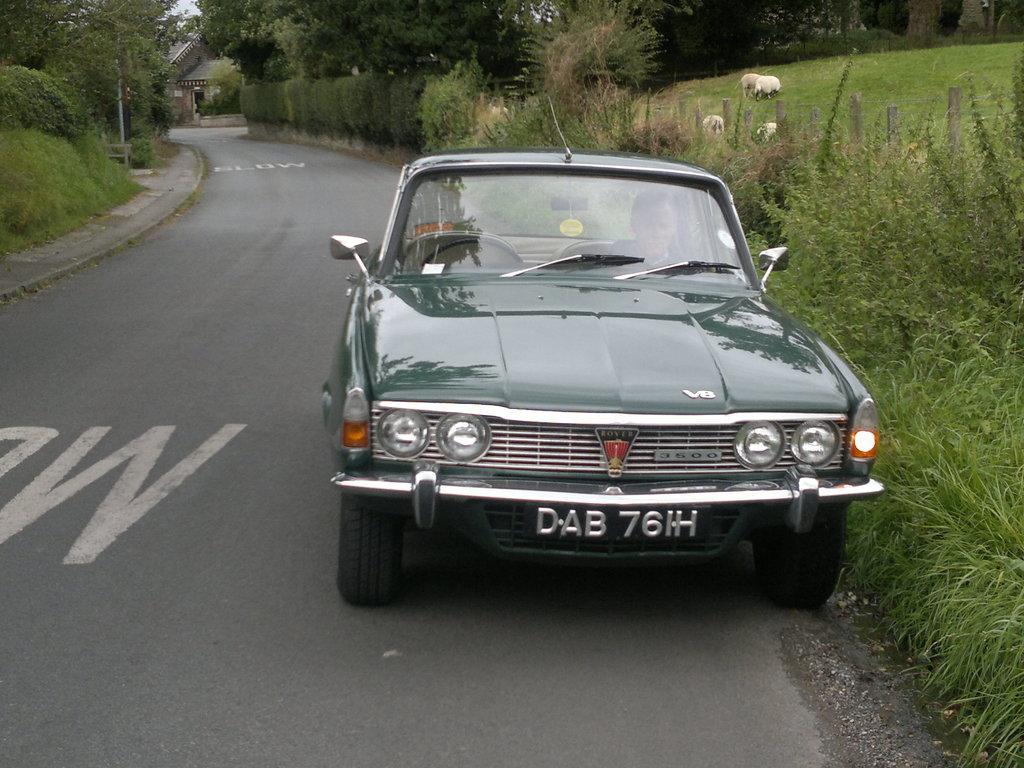How would you summarize this image in a sentence or two? In this image I can see a car in green color, background I can see a house, trees in green color and the sky is in white color. 